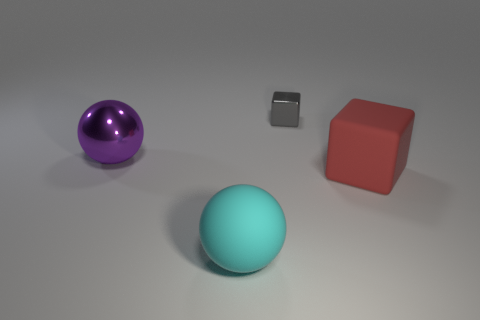How many brown objects are either small spheres or small metal objects?
Make the answer very short. 0. There is a large ball behind the sphere that is in front of the large red matte cube; are there any rubber spheres behind it?
Your response must be concise. No. Is there any other thing that is the same material as the large purple sphere?
Offer a terse response. Yes. How many tiny things are yellow matte blocks or red objects?
Your response must be concise. 0. Does the small gray thing that is on the left side of the large red rubber object have the same shape as the large red object?
Your answer should be compact. Yes. Are there fewer tiny blue matte spheres than red blocks?
Ensure brevity in your answer.  Yes. Is there anything else that is the same color as the large matte sphere?
Keep it short and to the point. No. There is a rubber object in front of the big red object; what is its shape?
Your response must be concise. Sphere. There is a large matte block; is its color the same as the large rubber object left of the small metal cube?
Give a very brief answer. No. Are there the same number of large metal balls that are behind the big purple metal ball and large objects in front of the cyan matte object?
Your response must be concise. Yes. 